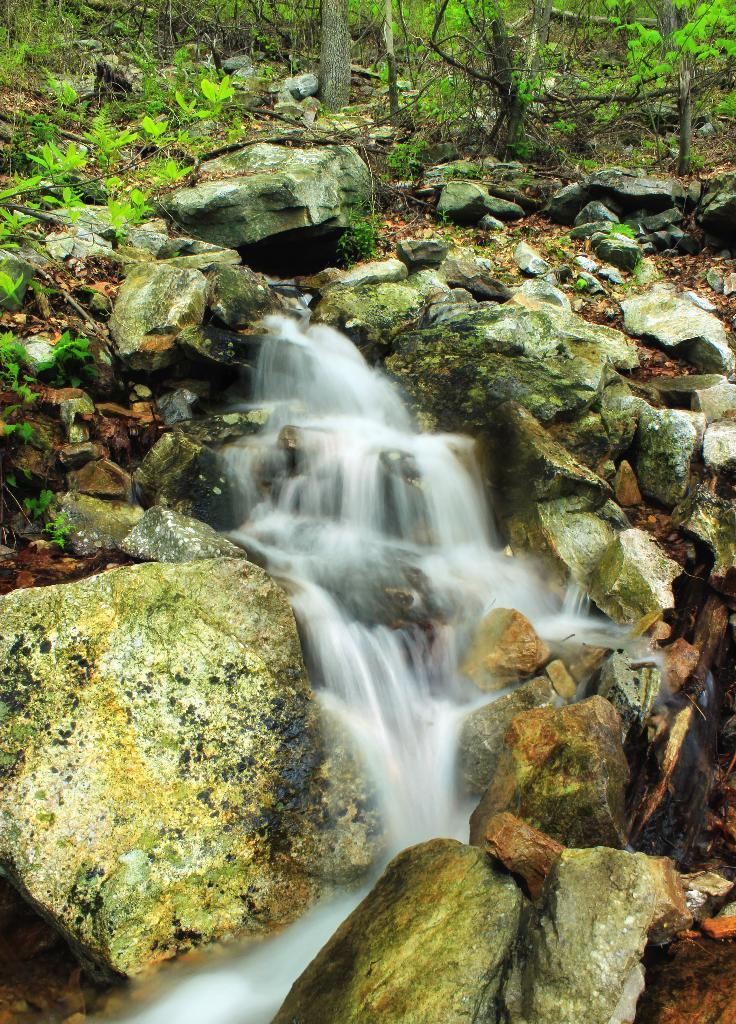What is the primary feature of the stones in the image? The stones have water on them in the image. What type of vegetation can be seen in the image? There are plants and trees in the image. What type of land feature is present in the image? There are rocks on the land in the image. What color is the cabbage in the image? There is no cabbage present in the image. Can you describe the bite marks on the plants in the image? There are no bite marks on the plants in the image. 